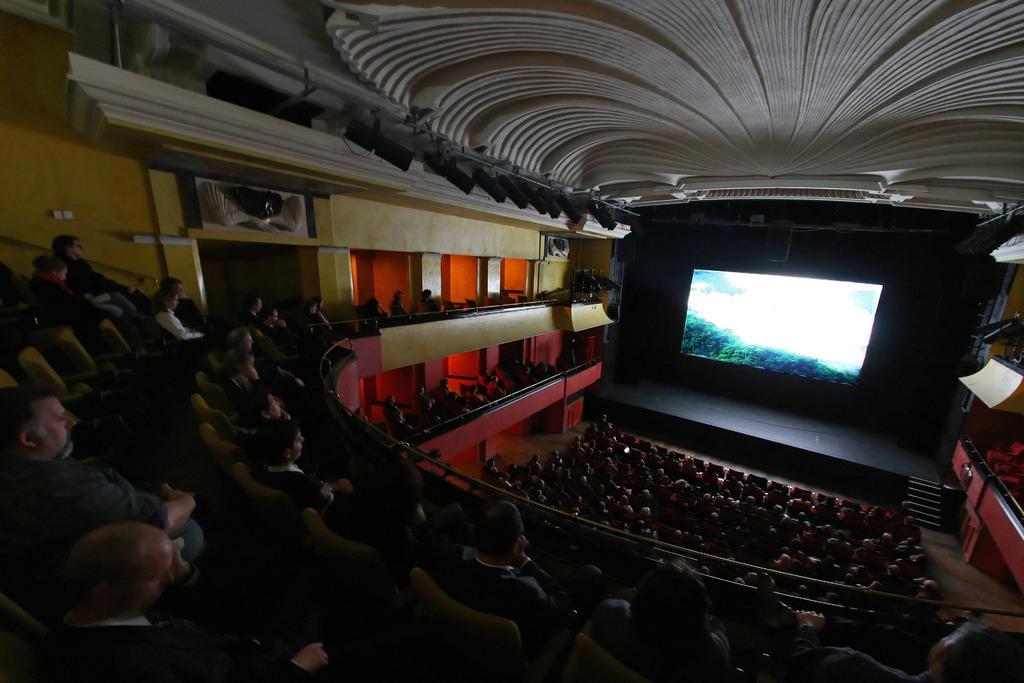Describe this image in one or two sentences. This picture looks like a theater and I can see few people are seated in the chairs and I can see screen. 